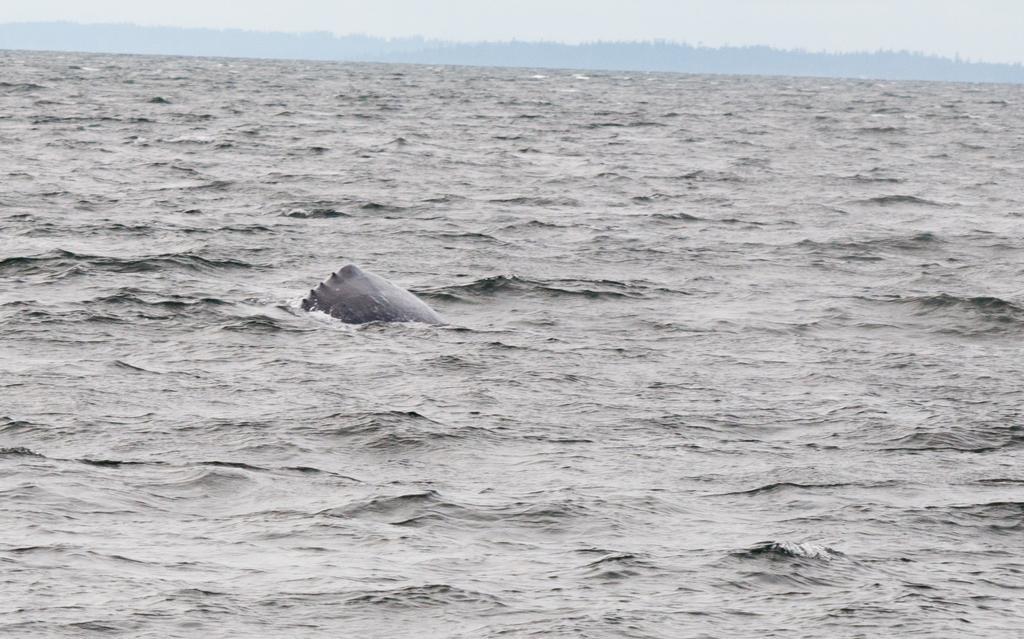Please provide a concise description of this image. In this image we can see there is an object in the river. In the background there is a sky. 